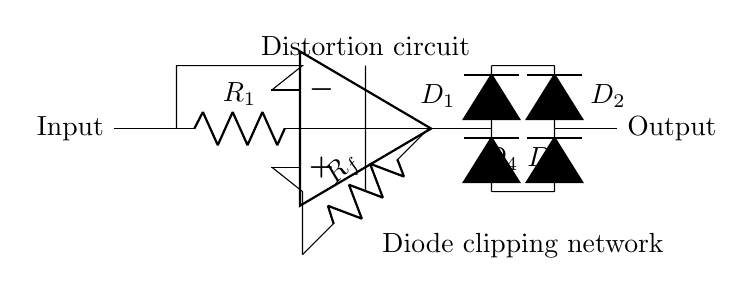What is the purpose of the operational amplifier in this circuit? The operational amplifier amplifies the input guitar signal, increasing its strength before it undergoes distortion through diode clipping.
Answer: Amplification How many diodes are present in the circuit? By counting the diodes labeled D1, D2, D3, and D4 in the diagram, we find there are four diodes used for clipping.
Answer: Four What type of configuration does the op-amp use in this circuit? The op-amp is configured typically as a non-inverting amplifier based on the feedback circuit with resistor R_f.
Answer: Non-inverting What component limits the output voltage swing? The diodes (D1, D2, D3, D4) in the circuit are responsible for limiting the output voltage by clipping it at certain levels.
Answer: Diodes What does the resistor R_f do in this circuit? The resistor R_f sets the gain of the operational amplifier, thereby influencing the level of distortion based on the signal feedback.
Answer: Gain setting How is the output signal affected by the diodes? The diodes create clipping of the signal, resulting in distortion by preventing the output voltage from exceeding certain thresholds during high peaks.
Answer: Clipping distortion 